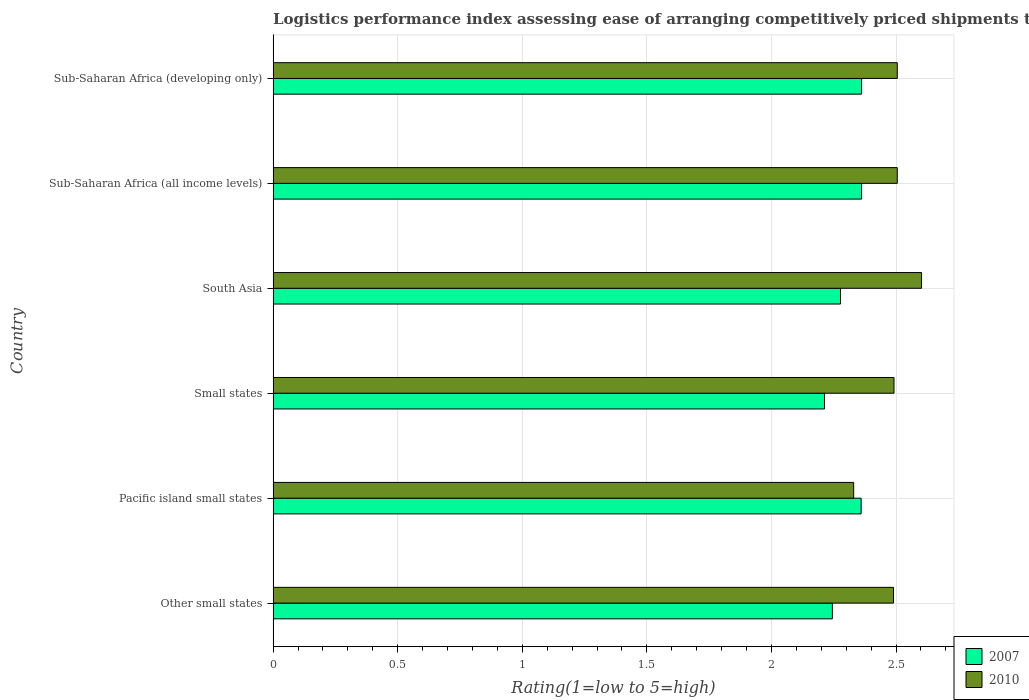How many different coloured bars are there?
Provide a short and direct response. 2. How many groups of bars are there?
Provide a short and direct response. 6. Are the number of bars per tick equal to the number of legend labels?
Give a very brief answer. Yes. How many bars are there on the 2nd tick from the top?
Your answer should be very brief. 2. How many bars are there on the 2nd tick from the bottom?
Offer a very short reply. 2. What is the label of the 6th group of bars from the top?
Provide a short and direct response. Other small states. What is the Logistic performance index in 2010 in Small states?
Your response must be concise. 2.49. Across all countries, what is the maximum Logistic performance index in 2007?
Provide a succinct answer. 2.36. Across all countries, what is the minimum Logistic performance index in 2010?
Give a very brief answer. 2.33. In which country was the Logistic performance index in 2010 maximum?
Provide a short and direct response. South Asia. In which country was the Logistic performance index in 2007 minimum?
Provide a succinct answer. Small states. What is the total Logistic performance index in 2007 in the graph?
Offer a terse response. 13.82. What is the difference between the Logistic performance index in 2007 in Other small states and that in Small states?
Your answer should be very brief. 0.03. What is the difference between the Logistic performance index in 2010 in Sub-Saharan Africa (all income levels) and the Logistic performance index in 2007 in South Asia?
Give a very brief answer. 0.23. What is the average Logistic performance index in 2007 per country?
Keep it short and to the point. 2.3. What is the difference between the Logistic performance index in 2007 and Logistic performance index in 2010 in South Asia?
Your response must be concise. -0.33. In how many countries, is the Logistic performance index in 2007 greater than 0.7 ?
Keep it short and to the point. 6. What is the ratio of the Logistic performance index in 2007 in Pacific island small states to that in South Asia?
Keep it short and to the point. 1.04. Is the Logistic performance index in 2010 in South Asia less than that in Sub-Saharan Africa (all income levels)?
Provide a succinct answer. No. What is the difference between the highest and the second highest Logistic performance index in 2010?
Your answer should be very brief. 0.1. What is the difference between the highest and the lowest Logistic performance index in 2010?
Make the answer very short. 0.27. Is the sum of the Logistic performance index in 2010 in Sub-Saharan Africa (all income levels) and Sub-Saharan Africa (developing only) greater than the maximum Logistic performance index in 2007 across all countries?
Your answer should be very brief. Yes. What does the 1st bar from the bottom in Small states represents?
Your response must be concise. 2007. How many countries are there in the graph?
Keep it short and to the point. 6. Are the values on the major ticks of X-axis written in scientific E-notation?
Provide a short and direct response. No. Does the graph contain any zero values?
Offer a very short reply. No. Does the graph contain grids?
Make the answer very short. Yes. Where does the legend appear in the graph?
Your answer should be compact. Bottom right. How many legend labels are there?
Ensure brevity in your answer.  2. What is the title of the graph?
Offer a terse response. Logistics performance index assessing ease of arranging competitively priced shipments to markets. Does "2003" appear as one of the legend labels in the graph?
Give a very brief answer. No. What is the label or title of the X-axis?
Your response must be concise. Rating(1=low to 5=high). What is the Rating(1=low to 5=high) of 2007 in Other small states?
Provide a short and direct response. 2.24. What is the Rating(1=low to 5=high) of 2010 in Other small states?
Offer a very short reply. 2.49. What is the Rating(1=low to 5=high) of 2007 in Pacific island small states?
Offer a very short reply. 2.36. What is the Rating(1=low to 5=high) of 2010 in Pacific island small states?
Provide a succinct answer. 2.33. What is the Rating(1=low to 5=high) in 2007 in Small states?
Your answer should be compact. 2.21. What is the Rating(1=low to 5=high) in 2010 in Small states?
Make the answer very short. 2.49. What is the Rating(1=low to 5=high) of 2007 in South Asia?
Offer a terse response. 2.28. What is the Rating(1=low to 5=high) in 2010 in South Asia?
Provide a succinct answer. 2.6. What is the Rating(1=low to 5=high) in 2007 in Sub-Saharan Africa (all income levels)?
Your response must be concise. 2.36. What is the Rating(1=low to 5=high) of 2010 in Sub-Saharan Africa (all income levels)?
Your answer should be very brief. 2.5. What is the Rating(1=low to 5=high) of 2007 in Sub-Saharan Africa (developing only)?
Offer a terse response. 2.36. What is the Rating(1=low to 5=high) in 2010 in Sub-Saharan Africa (developing only)?
Keep it short and to the point. 2.5. Across all countries, what is the maximum Rating(1=low to 5=high) in 2007?
Give a very brief answer. 2.36. Across all countries, what is the maximum Rating(1=low to 5=high) of 2010?
Your answer should be very brief. 2.6. Across all countries, what is the minimum Rating(1=low to 5=high) in 2007?
Your answer should be very brief. 2.21. Across all countries, what is the minimum Rating(1=low to 5=high) of 2010?
Your answer should be compact. 2.33. What is the total Rating(1=low to 5=high) of 2007 in the graph?
Keep it short and to the point. 13.82. What is the total Rating(1=low to 5=high) of 2010 in the graph?
Keep it short and to the point. 14.92. What is the difference between the Rating(1=low to 5=high) in 2007 in Other small states and that in Pacific island small states?
Offer a very short reply. -0.12. What is the difference between the Rating(1=low to 5=high) in 2010 in Other small states and that in Pacific island small states?
Ensure brevity in your answer.  0.16. What is the difference between the Rating(1=low to 5=high) in 2007 in Other small states and that in Small states?
Provide a short and direct response. 0.03. What is the difference between the Rating(1=low to 5=high) of 2010 in Other small states and that in Small states?
Provide a succinct answer. -0. What is the difference between the Rating(1=low to 5=high) in 2007 in Other small states and that in South Asia?
Your answer should be compact. -0.03. What is the difference between the Rating(1=low to 5=high) in 2010 in Other small states and that in South Asia?
Provide a succinct answer. -0.11. What is the difference between the Rating(1=low to 5=high) in 2007 in Other small states and that in Sub-Saharan Africa (all income levels)?
Offer a very short reply. -0.12. What is the difference between the Rating(1=low to 5=high) in 2010 in Other small states and that in Sub-Saharan Africa (all income levels)?
Your answer should be very brief. -0.01. What is the difference between the Rating(1=low to 5=high) of 2007 in Other small states and that in Sub-Saharan Africa (developing only)?
Offer a very short reply. -0.12. What is the difference between the Rating(1=low to 5=high) in 2010 in Other small states and that in Sub-Saharan Africa (developing only)?
Provide a succinct answer. -0.01. What is the difference between the Rating(1=low to 5=high) of 2007 in Pacific island small states and that in Small states?
Give a very brief answer. 0.15. What is the difference between the Rating(1=low to 5=high) of 2010 in Pacific island small states and that in Small states?
Make the answer very short. -0.16. What is the difference between the Rating(1=low to 5=high) of 2007 in Pacific island small states and that in South Asia?
Your answer should be compact. 0.08. What is the difference between the Rating(1=low to 5=high) in 2010 in Pacific island small states and that in South Asia?
Provide a short and direct response. -0.27. What is the difference between the Rating(1=low to 5=high) of 2007 in Pacific island small states and that in Sub-Saharan Africa (all income levels)?
Give a very brief answer. -0. What is the difference between the Rating(1=low to 5=high) in 2010 in Pacific island small states and that in Sub-Saharan Africa (all income levels)?
Offer a very short reply. -0.17. What is the difference between the Rating(1=low to 5=high) of 2007 in Pacific island small states and that in Sub-Saharan Africa (developing only)?
Make the answer very short. -0. What is the difference between the Rating(1=low to 5=high) in 2010 in Pacific island small states and that in Sub-Saharan Africa (developing only)?
Provide a succinct answer. -0.17. What is the difference between the Rating(1=low to 5=high) of 2007 in Small states and that in South Asia?
Provide a short and direct response. -0.06. What is the difference between the Rating(1=low to 5=high) of 2010 in Small states and that in South Asia?
Ensure brevity in your answer.  -0.11. What is the difference between the Rating(1=low to 5=high) in 2007 in Small states and that in Sub-Saharan Africa (all income levels)?
Your answer should be compact. -0.15. What is the difference between the Rating(1=low to 5=high) in 2010 in Small states and that in Sub-Saharan Africa (all income levels)?
Your answer should be compact. -0.01. What is the difference between the Rating(1=low to 5=high) in 2007 in Small states and that in Sub-Saharan Africa (developing only)?
Give a very brief answer. -0.15. What is the difference between the Rating(1=low to 5=high) in 2010 in Small states and that in Sub-Saharan Africa (developing only)?
Make the answer very short. -0.01. What is the difference between the Rating(1=low to 5=high) of 2007 in South Asia and that in Sub-Saharan Africa (all income levels)?
Your answer should be compact. -0.08. What is the difference between the Rating(1=low to 5=high) of 2010 in South Asia and that in Sub-Saharan Africa (all income levels)?
Give a very brief answer. 0.1. What is the difference between the Rating(1=low to 5=high) of 2007 in South Asia and that in Sub-Saharan Africa (developing only)?
Offer a very short reply. -0.08. What is the difference between the Rating(1=low to 5=high) of 2010 in South Asia and that in Sub-Saharan Africa (developing only)?
Your answer should be compact. 0.1. What is the difference between the Rating(1=low to 5=high) in 2007 in Sub-Saharan Africa (all income levels) and that in Sub-Saharan Africa (developing only)?
Your response must be concise. 0. What is the difference between the Rating(1=low to 5=high) of 2010 in Sub-Saharan Africa (all income levels) and that in Sub-Saharan Africa (developing only)?
Ensure brevity in your answer.  0. What is the difference between the Rating(1=low to 5=high) of 2007 in Other small states and the Rating(1=low to 5=high) of 2010 in Pacific island small states?
Provide a succinct answer. -0.09. What is the difference between the Rating(1=low to 5=high) of 2007 in Other small states and the Rating(1=low to 5=high) of 2010 in Small states?
Make the answer very short. -0.25. What is the difference between the Rating(1=low to 5=high) of 2007 in Other small states and the Rating(1=low to 5=high) of 2010 in South Asia?
Provide a short and direct response. -0.36. What is the difference between the Rating(1=low to 5=high) of 2007 in Other small states and the Rating(1=low to 5=high) of 2010 in Sub-Saharan Africa (all income levels)?
Offer a very short reply. -0.26. What is the difference between the Rating(1=low to 5=high) in 2007 in Other small states and the Rating(1=low to 5=high) in 2010 in Sub-Saharan Africa (developing only)?
Provide a short and direct response. -0.26. What is the difference between the Rating(1=low to 5=high) of 2007 in Pacific island small states and the Rating(1=low to 5=high) of 2010 in Small states?
Make the answer very short. -0.13. What is the difference between the Rating(1=low to 5=high) of 2007 in Pacific island small states and the Rating(1=low to 5=high) of 2010 in South Asia?
Make the answer very short. -0.24. What is the difference between the Rating(1=low to 5=high) of 2007 in Pacific island small states and the Rating(1=low to 5=high) of 2010 in Sub-Saharan Africa (all income levels)?
Your answer should be compact. -0.14. What is the difference between the Rating(1=low to 5=high) of 2007 in Pacific island small states and the Rating(1=low to 5=high) of 2010 in Sub-Saharan Africa (developing only)?
Make the answer very short. -0.14. What is the difference between the Rating(1=low to 5=high) of 2007 in Small states and the Rating(1=low to 5=high) of 2010 in South Asia?
Keep it short and to the point. -0.39. What is the difference between the Rating(1=low to 5=high) in 2007 in Small states and the Rating(1=low to 5=high) in 2010 in Sub-Saharan Africa (all income levels)?
Provide a short and direct response. -0.29. What is the difference between the Rating(1=low to 5=high) in 2007 in Small states and the Rating(1=low to 5=high) in 2010 in Sub-Saharan Africa (developing only)?
Make the answer very short. -0.29. What is the difference between the Rating(1=low to 5=high) in 2007 in South Asia and the Rating(1=low to 5=high) in 2010 in Sub-Saharan Africa (all income levels)?
Provide a short and direct response. -0.23. What is the difference between the Rating(1=low to 5=high) of 2007 in South Asia and the Rating(1=low to 5=high) of 2010 in Sub-Saharan Africa (developing only)?
Your response must be concise. -0.23. What is the difference between the Rating(1=low to 5=high) of 2007 in Sub-Saharan Africa (all income levels) and the Rating(1=low to 5=high) of 2010 in Sub-Saharan Africa (developing only)?
Ensure brevity in your answer.  -0.14. What is the average Rating(1=low to 5=high) of 2007 per country?
Make the answer very short. 2.3. What is the average Rating(1=low to 5=high) of 2010 per country?
Make the answer very short. 2.49. What is the difference between the Rating(1=low to 5=high) in 2007 and Rating(1=low to 5=high) in 2010 in Other small states?
Your answer should be very brief. -0.25. What is the difference between the Rating(1=low to 5=high) of 2007 and Rating(1=low to 5=high) of 2010 in Small states?
Ensure brevity in your answer.  -0.28. What is the difference between the Rating(1=low to 5=high) in 2007 and Rating(1=low to 5=high) in 2010 in South Asia?
Provide a succinct answer. -0.33. What is the difference between the Rating(1=low to 5=high) of 2007 and Rating(1=low to 5=high) of 2010 in Sub-Saharan Africa (all income levels)?
Provide a short and direct response. -0.14. What is the difference between the Rating(1=low to 5=high) of 2007 and Rating(1=low to 5=high) of 2010 in Sub-Saharan Africa (developing only)?
Offer a very short reply. -0.14. What is the ratio of the Rating(1=low to 5=high) of 2007 in Other small states to that in Pacific island small states?
Provide a succinct answer. 0.95. What is the ratio of the Rating(1=low to 5=high) of 2010 in Other small states to that in Pacific island small states?
Your answer should be very brief. 1.07. What is the ratio of the Rating(1=low to 5=high) in 2007 in Other small states to that in Small states?
Provide a succinct answer. 1.01. What is the ratio of the Rating(1=low to 5=high) in 2010 in Other small states to that in Small states?
Provide a succinct answer. 1. What is the ratio of the Rating(1=low to 5=high) of 2007 in Other small states to that in South Asia?
Offer a terse response. 0.99. What is the ratio of the Rating(1=low to 5=high) of 2010 in Other small states to that in South Asia?
Offer a very short reply. 0.96. What is the ratio of the Rating(1=low to 5=high) of 2007 in Other small states to that in Sub-Saharan Africa (all income levels)?
Give a very brief answer. 0.95. What is the ratio of the Rating(1=low to 5=high) of 2010 in Other small states to that in Sub-Saharan Africa (all income levels)?
Give a very brief answer. 0.99. What is the ratio of the Rating(1=low to 5=high) of 2007 in Other small states to that in Sub-Saharan Africa (developing only)?
Your answer should be very brief. 0.95. What is the ratio of the Rating(1=low to 5=high) in 2010 in Other small states to that in Sub-Saharan Africa (developing only)?
Offer a terse response. 0.99. What is the ratio of the Rating(1=low to 5=high) of 2007 in Pacific island small states to that in Small states?
Provide a succinct answer. 1.07. What is the ratio of the Rating(1=low to 5=high) of 2010 in Pacific island small states to that in Small states?
Offer a very short reply. 0.94. What is the ratio of the Rating(1=low to 5=high) of 2007 in Pacific island small states to that in South Asia?
Offer a terse response. 1.04. What is the ratio of the Rating(1=low to 5=high) in 2010 in Pacific island small states to that in South Asia?
Give a very brief answer. 0.9. What is the ratio of the Rating(1=low to 5=high) in 2007 in Pacific island small states to that in Sub-Saharan Africa (all income levels)?
Offer a very short reply. 1. What is the ratio of the Rating(1=low to 5=high) in 2010 in Pacific island small states to that in Sub-Saharan Africa (all income levels)?
Offer a very short reply. 0.93. What is the ratio of the Rating(1=low to 5=high) of 2007 in Pacific island small states to that in Sub-Saharan Africa (developing only)?
Give a very brief answer. 1. What is the ratio of the Rating(1=low to 5=high) of 2010 in Pacific island small states to that in Sub-Saharan Africa (developing only)?
Give a very brief answer. 0.93. What is the ratio of the Rating(1=low to 5=high) in 2007 in Small states to that in South Asia?
Provide a succinct answer. 0.97. What is the ratio of the Rating(1=low to 5=high) in 2010 in Small states to that in South Asia?
Keep it short and to the point. 0.96. What is the ratio of the Rating(1=low to 5=high) in 2007 in Small states to that in Sub-Saharan Africa (all income levels)?
Provide a short and direct response. 0.94. What is the ratio of the Rating(1=low to 5=high) in 2007 in Small states to that in Sub-Saharan Africa (developing only)?
Keep it short and to the point. 0.94. What is the ratio of the Rating(1=low to 5=high) in 2007 in South Asia to that in Sub-Saharan Africa (all income levels)?
Provide a succinct answer. 0.96. What is the ratio of the Rating(1=low to 5=high) in 2010 in South Asia to that in Sub-Saharan Africa (all income levels)?
Provide a succinct answer. 1.04. What is the ratio of the Rating(1=low to 5=high) of 2007 in South Asia to that in Sub-Saharan Africa (developing only)?
Make the answer very short. 0.96. What is the ratio of the Rating(1=low to 5=high) in 2010 in South Asia to that in Sub-Saharan Africa (developing only)?
Make the answer very short. 1.04. What is the difference between the highest and the second highest Rating(1=low to 5=high) in 2010?
Your answer should be compact. 0.1. What is the difference between the highest and the lowest Rating(1=low to 5=high) of 2007?
Offer a terse response. 0.15. What is the difference between the highest and the lowest Rating(1=low to 5=high) of 2010?
Make the answer very short. 0.27. 